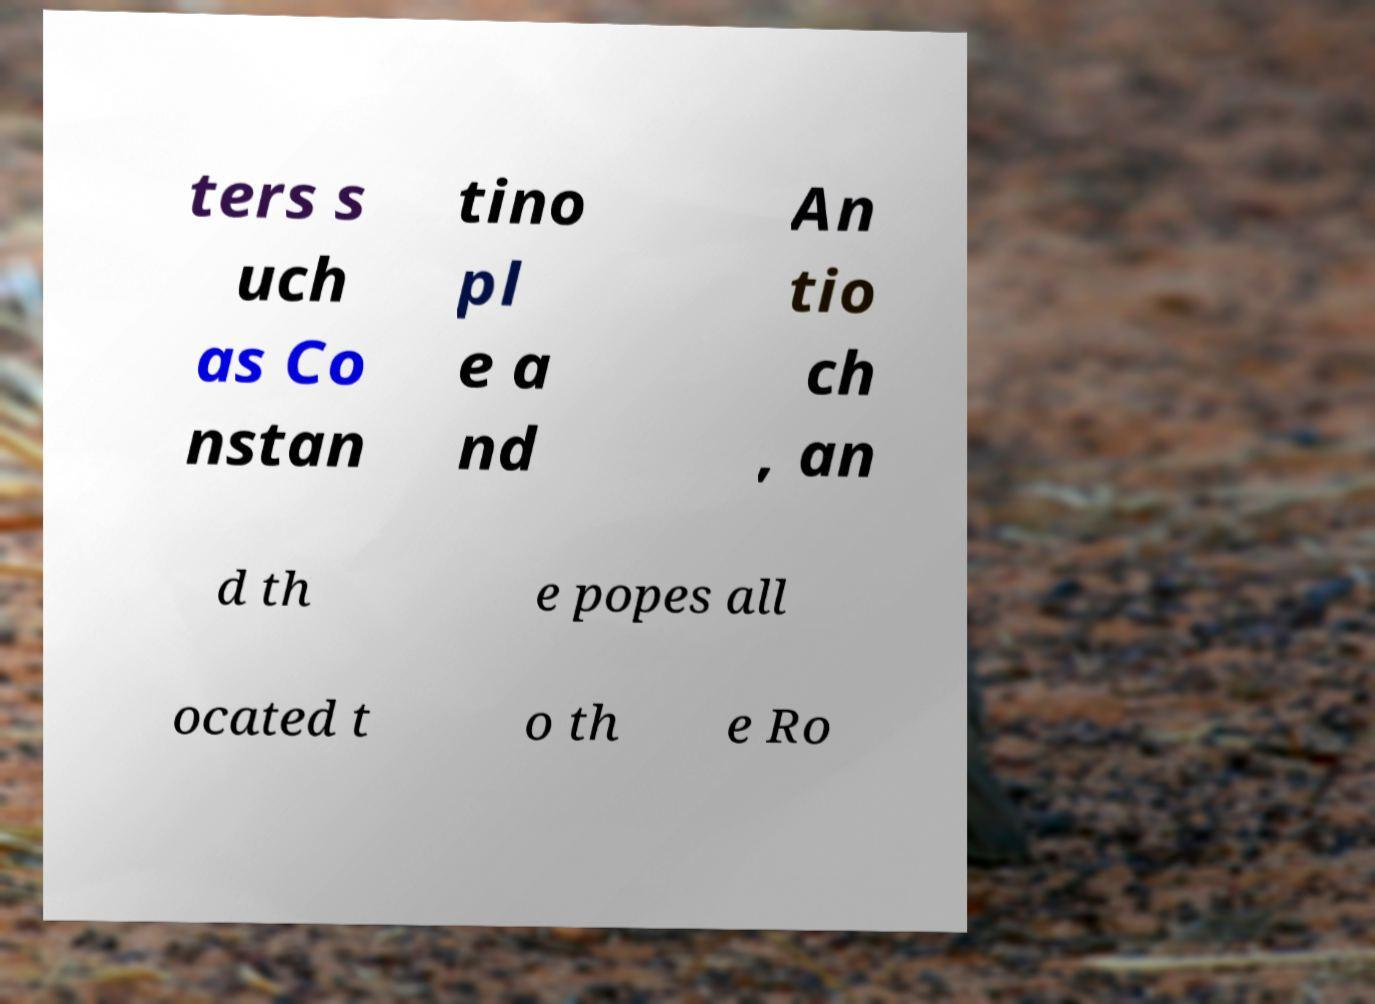Could you extract and type out the text from this image? ters s uch as Co nstan tino pl e a nd An tio ch , an d th e popes all ocated t o th e Ro 